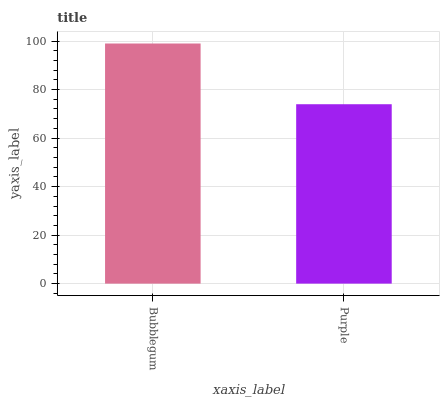Is Purple the minimum?
Answer yes or no. Yes. Is Bubblegum the maximum?
Answer yes or no. Yes. Is Purple the maximum?
Answer yes or no. No. Is Bubblegum greater than Purple?
Answer yes or no. Yes. Is Purple less than Bubblegum?
Answer yes or no. Yes. Is Purple greater than Bubblegum?
Answer yes or no. No. Is Bubblegum less than Purple?
Answer yes or no. No. Is Bubblegum the high median?
Answer yes or no. Yes. Is Purple the low median?
Answer yes or no. Yes. Is Purple the high median?
Answer yes or no. No. Is Bubblegum the low median?
Answer yes or no. No. 